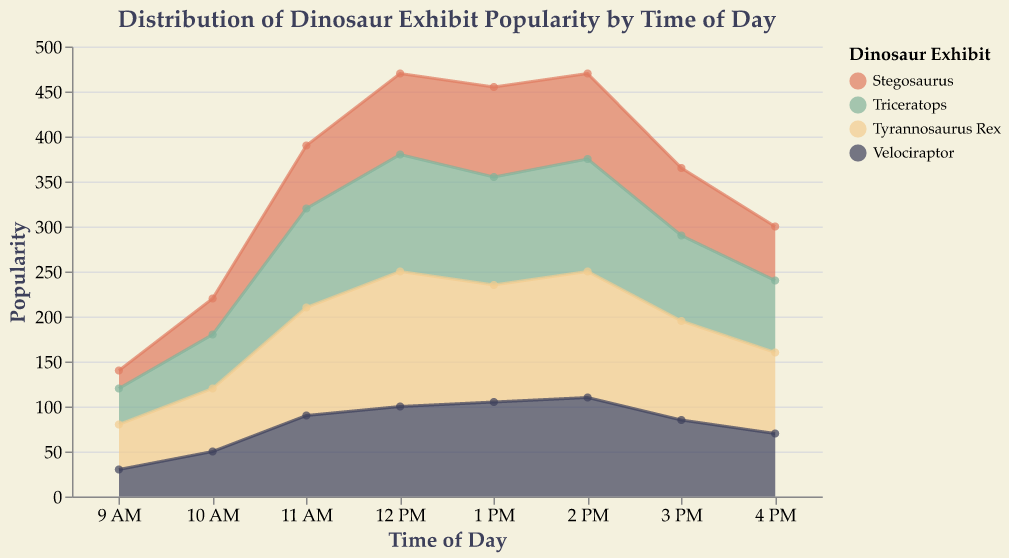What's the title of the chart? The title of the chart is displayed at the top and usually summarizes the chart's content.
Answer: Distribution of Dinosaur Exhibit Popularity by Time of Day What are the four dinosaur exhibits represented in the chart? To find the dinosaur exhibits, refer to the color legend on the right side of the chart.
Answer: Tyrannosaurus Rex, Triceratops, Velociraptor, Stegosaurus At what time is the Tyrannosaurus Rex exhibit the most popular? Look at the area representing the Tyrannosaurus Rex exhibit and find the peak point.
Answer: 12 PM Which dinosaur exhibit has the highest popularity at 1 PM? Compare the heights of the areas at the 1 PM mark for all exhibits.
Answer: Tyrannosaurus Rex What is the total popularity of all exhibits combined at 11 AM? Add the popularity values for all exhibits at 11 AM. 120 (Tyrannosaurus Rex) + 110 (Triceratops) + 90 (Velociraptor) + 70 (Stegosaurus) = 390.
Answer: 390 Which exhibit shows the least popularity at 9 AM? Compare the heights of the areas at the 9 AM mark for all exhibits to find the smallest one.
Answer: Stegosaurus How does the popularity of the Velociraptor exhibit change from 9 AM to 4 PM? Track the area representing Velociraptor from 9 AM to 4 PM and note the changes in height.
Answer: Increases to a peak at 2 PM and then decreases At what time is the Triceratops exhibit more popular than the Velociraptor exhibit? Compare the heights of the areas representing Triceratops and Velociraptor across the time axis.
Answer: 9 AM to 4 PM (all day) Which dinosaur exhibit generally shows the lowest overall popularity throughout the day? Compare the total areas under each exhibit’s curve to determine which is smallest.
Answer: Stegosaurus When is the popularity of all dinosaur exhibits combined the highest? Sum the heights of all areas at each time of the day to find the maximum combined value.
Answer: 12 PM 